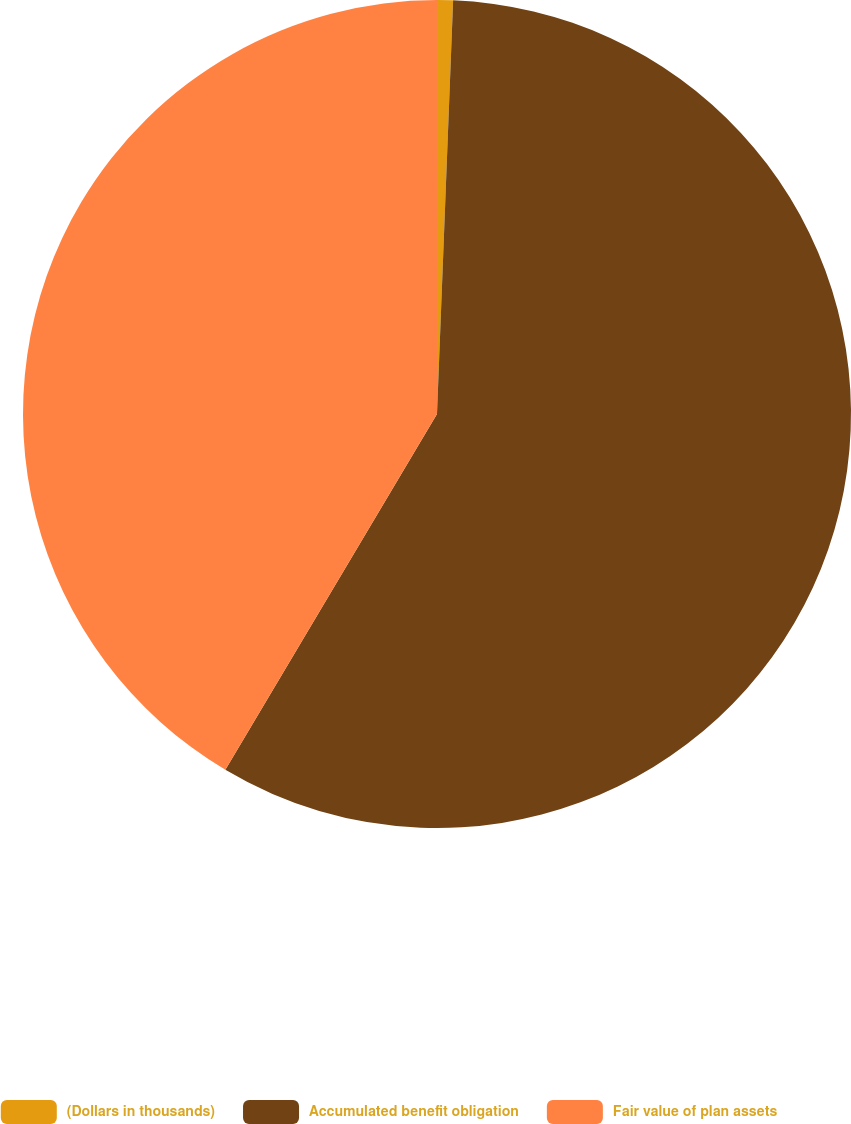Convert chart. <chart><loc_0><loc_0><loc_500><loc_500><pie_chart><fcel>(Dollars in thousands)<fcel>Accumulated benefit obligation<fcel>Fair value of plan assets<nl><fcel>0.62%<fcel>57.92%<fcel>41.46%<nl></chart> 